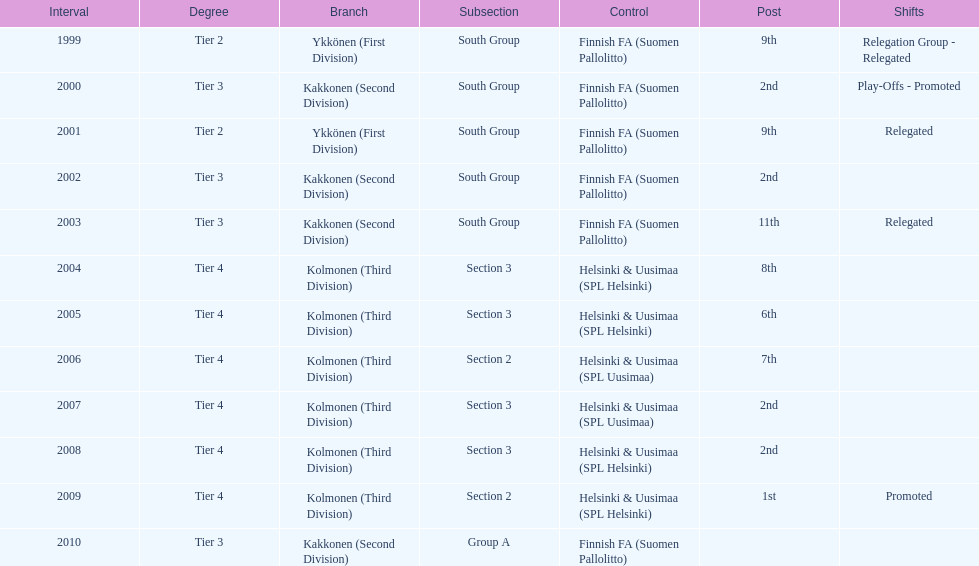Which administration has the least amount of division? Helsinki & Uusimaa (SPL Helsinki). 